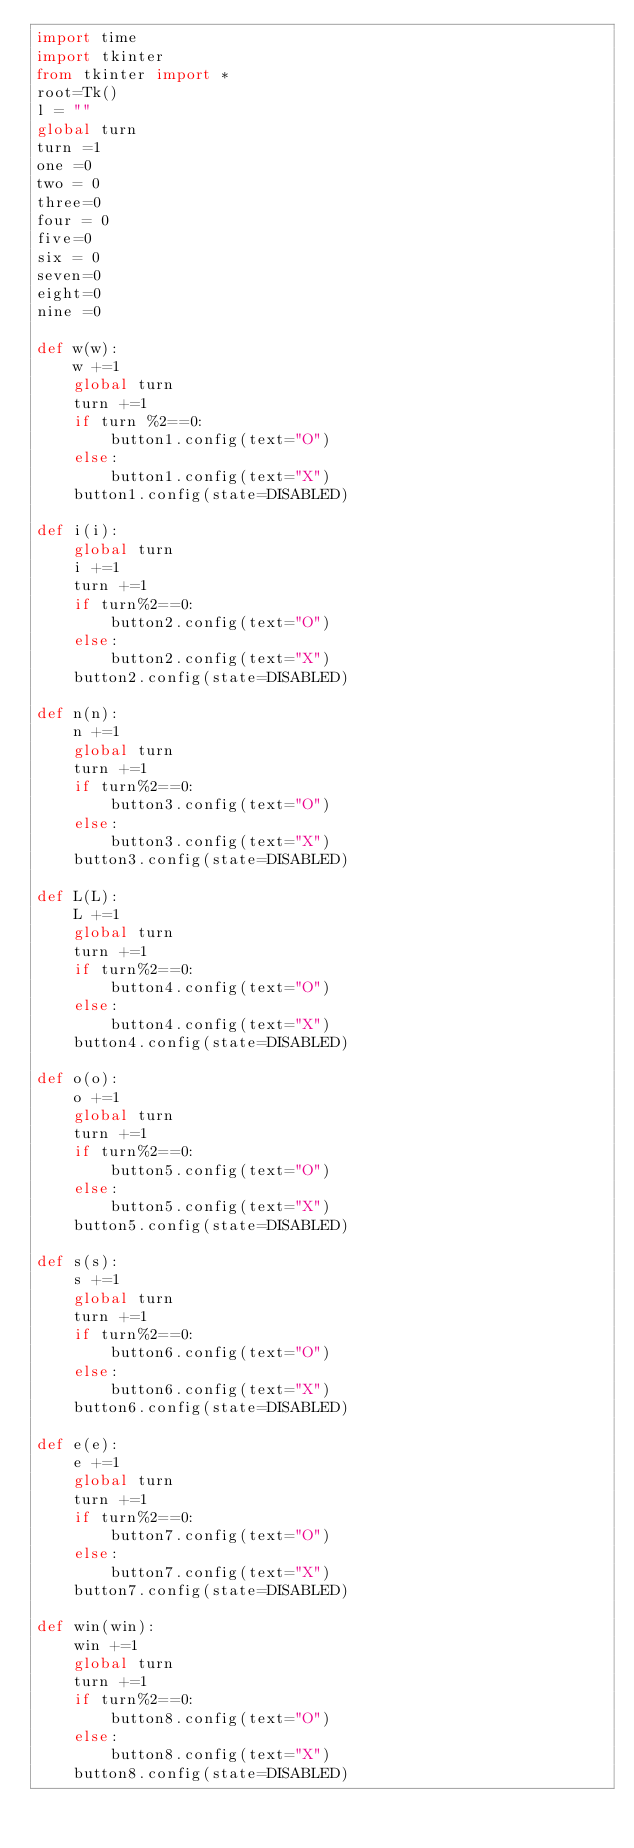<code> <loc_0><loc_0><loc_500><loc_500><_Python_>import time
import tkinter
from tkinter import *
root=Tk()
l = ""
global turn
turn =1
one =0
two = 0
three=0
four = 0
five=0
six = 0
seven=0
eight=0
nine =0

def w(w):
    w +=1
    global turn
    turn +=1
    if turn %2==0:
        button1.config(text="O")
    else:
        button1.config(text="X")
    button1.config(state=DISABLED)

def i(i):
    global turn
    i +=1
    turn +=1
    if turn%2==0:
        button2.config(text="O")
    else:
        button2.config(text="X")
    button2.config(state=DISABLED)

def n(n):
    n +=1
    global turn
    turn +=1
    if turn%2==0:
        button3.config(text="O")
    else:
        button3.config(text="X")
    button3.config(state=DISABLED)

def L(L):
    L +=1
    global turn
    turn +=1
    if turn%2==0:
        button4.config(text="O")
    else:
        button4.config(text="X")
    button4.config(state=DISABLED)

def o(o):
    o +=1
    global turn
    turn +=1
    if turn%2==0:
        button5.config(text="O")
    else:
        button5.config(text="X")
    button5.config(state=DISABLED)

def s(s):
    s +=1
    global turn
    turn +=1
    if turn%2==0:
        button6.config(text="O")
    else:
        button6.config(text="X")
    button6.config(state=DISABLED)

def e(e):
    e +=1
    global turn
    turn +=1
    if turn%2==0:
        button7.config(text="O")
    else:
        button7.config(text="X")
    button7.config(state=DISABLED)

def win(win):
    win +=1
    global turn
    turn +=1
    if turn%2==0:
        button8.config(text="O")
    else:
        button8.config(text="X")
    button8.config(state=DISABLED)
</code> 